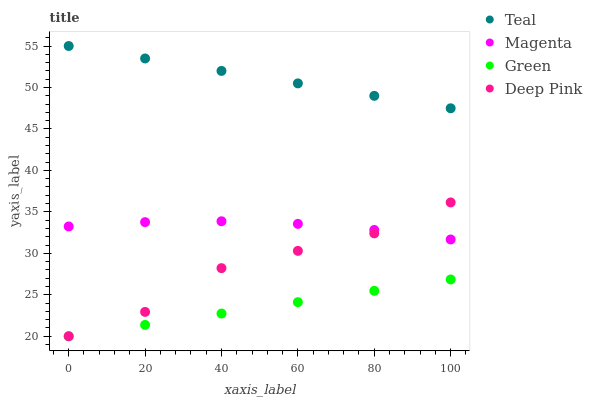Does Green have the minimum area under the curve?
Answer yes or no. Yes. Does Teal have the maximum area under the curve?
Answer yes or no. Yes. Does Deep Pink have the minimum area under the curve?
Answer yes or no. No. Does Deep Pink have the maximum area under the curve?
Answer yes or no. No. Is Teal the smoothest?
Answer yes or no. Yes. Is Deep Pink the roughest?
Answer yes or no. Yes. Is Green the smoothest?
Answer yes or no. No. Is Green the roughest?
Answer yes or no. No. Does Deep Pink have the lowest value?
Answer yes or no. Yes. Does Teal have the lowest value?
Answer yes or no. No. Does Teal have the highest value?
Answer yes or no. Yes. Does Deep Pink have the highest value?
Answer yes or no. No. Is Deep Pink less than Teal?
Answer yes or no. Yes. Is Magenta greater than Green?
Answer yes or no. Yes. Does Deep Pink intersect Green?
Answer yes or no. Yes. Is Deep Pink less than Green?
Answer yes or no. No. Is Deep Pink greater than Green?
Answer yes or no. No. Does Deep Pink intersect Teal?
Answer yes or no. No. 